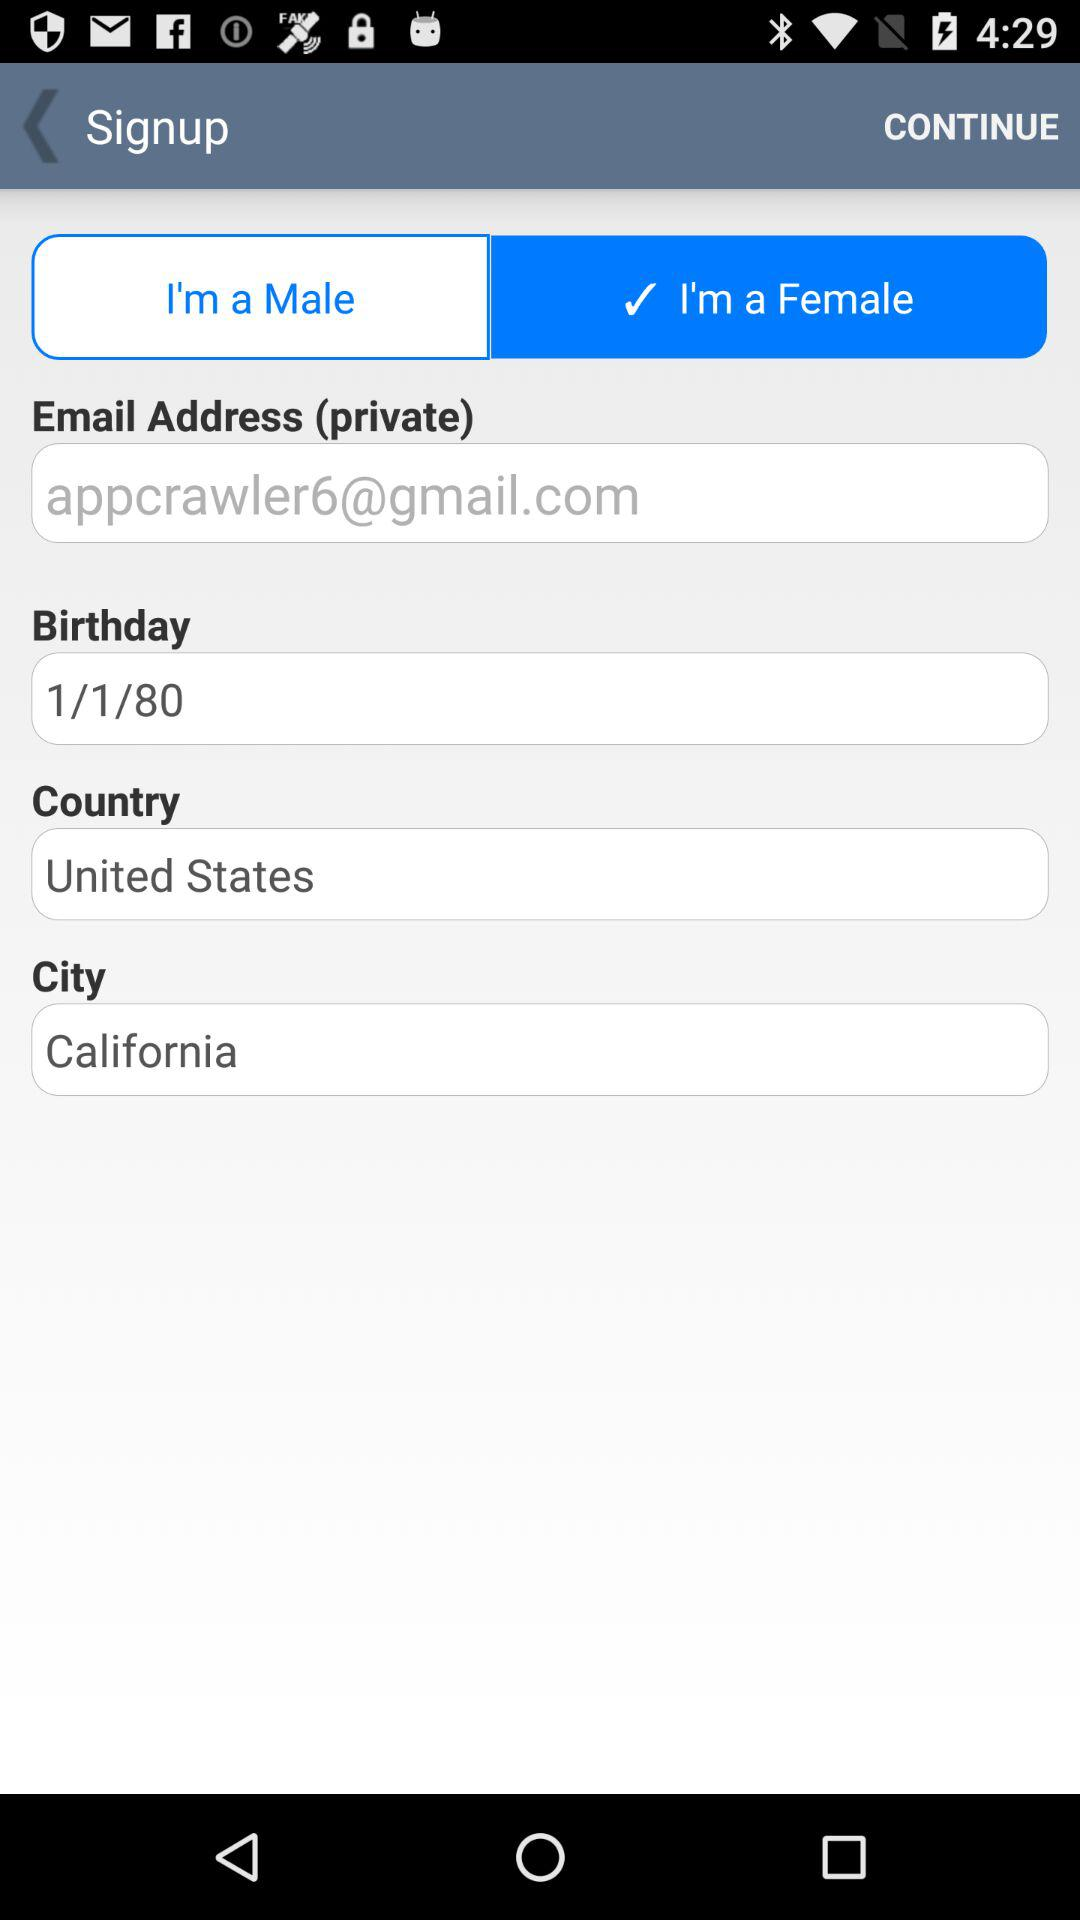Which country is selected? The selected country is the United States. 